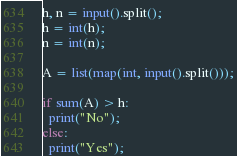Convert code to text. <code><loc_0><loc_0><loc_500><loc_500><_Python_>h, n = input().split();
h = int(h);
n = int(n);

A = list(map(int, input().split()));

if sum(A) > h:
  print("No");
else:
  print("Yes");
</code> 